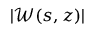<formula> <loc_0><loc_0><loc_500><loc_500>| \ m a t h s c r { W } ( s , z ) |</formula> 